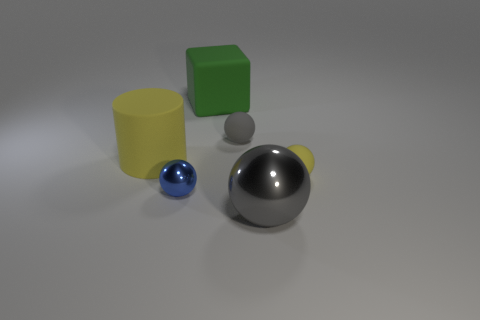Subtract all gray metal balls. How many balls are left? 3 Subtract all green cubes. How many gray balls are left? 2 Subtract all blue spheres. How many spheres are left? 3 Add 2 cubes. How many objects exist? 8 Subtract all green balls. Subtract all brown cylinders. How many balls are left? 4 Subtract all cylinders. How many objects are left? 5 Subtract all brown metal things. Subtract all small gray things. How many objects are left? 5 Add 6 tiny blue balls. How many tiny blue balls are left? 7 Add 2 matte things. How many matte things exist? 6 Subtract 0 blue cylinders. How many objects are left? 6 